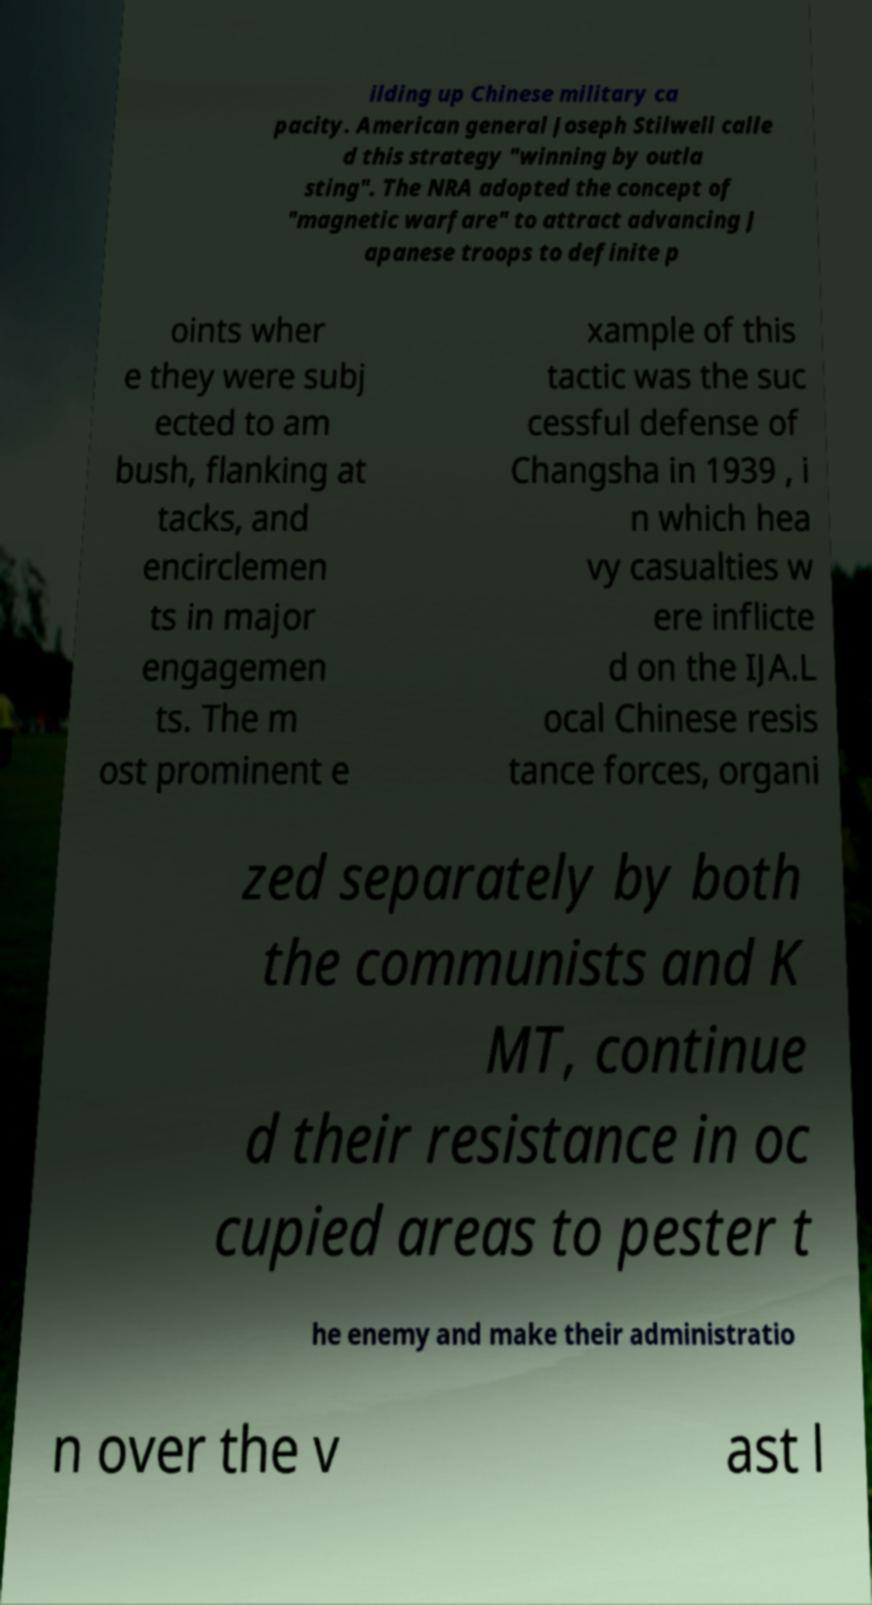What messages or text are displayed in this image? I need them in a readable, typed format. ilding up Chinese military ca pacity. American general Joseph Stilwell calle d this strategy "winning by outla sting". The NRA adopted the concept of "magnetic warfare" to attract advancing J apanese troops to definite p oints wher e they were subj ected to am bush, flanking at tacks, and encirclemen ts in major engagemen ts. The m ost prominent e xample of this tactic was the suc cessful defense of Changsha in 1939 , i n which hea vy casualties w ere inflicte d on the IJA.L ocal Chinese resis tance forces, organi zed separately by both the communists and K MT, continue d their resistance in oc cupied areas to pester t he enemy and make their administratio n over the v ast l 